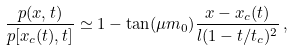<formula> <loc_0><loc_0><loc_500><loc_500>\frac { p ( x , t ) } { p [ x _ { c } ( t ) , t ] } \simeq 1 - \tan ( \mu m _ { 0 } ) \frac { x - x _ { c } ( t ) } { l ( 1 - t / t _ { c } ) ^ { 2 } } \, ,</formula> 